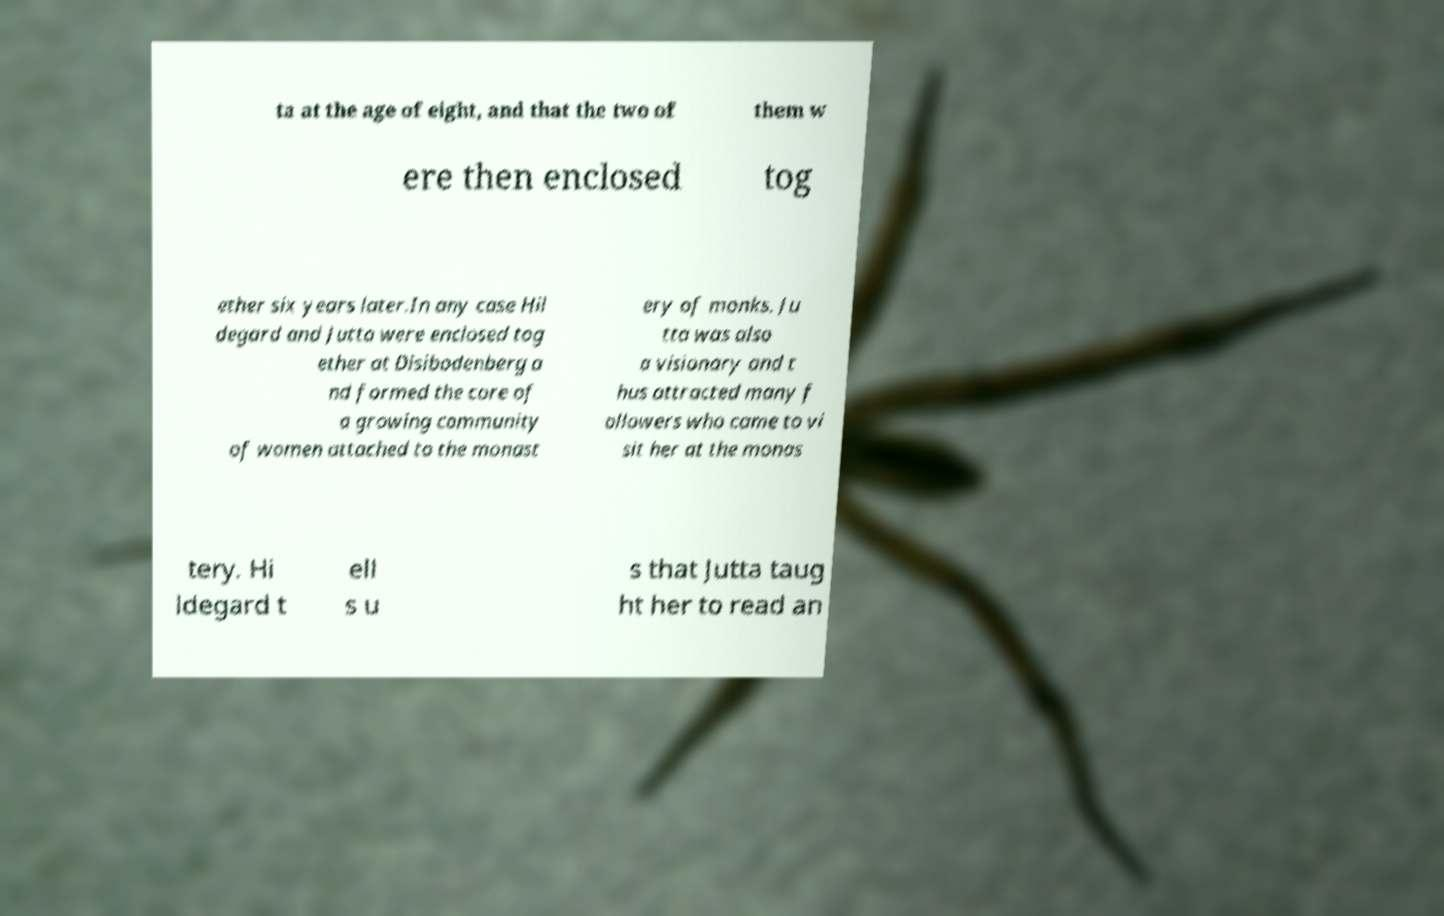Could you extract and type out the text from this image? ta at the age of eight, and that the two of them w ere then enclosed tog ether six years later.In any case Hil degard and Jutta were enclosed tog ether at Disibodenberg a nd formed the core of a growing community of women attached to the monast ery of monks. Ju tta was also a visionary and t hus attracted many f ollowers who came to vi sit her at the monas tery. Hi ldegard t ell s u s that Jutta taug ht her to read an 